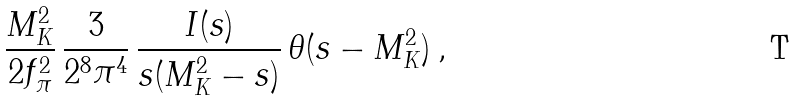Convert formula to latex. <formula><loc_0><loc_0><loc_500><loc_500>\frac { M _ { K } ^ { 2 } } { 2 f _ { \pi } ^ { 2 } } \, \frac { 3 } { 2 ^ { 8 } \pi ^ { 4 } } \, \frac { I ( s ) } { s ( M _ { K } ^ { 2 } - s ) } \, \theta ( s - M _ { K } ^ { 2 } ) \, ,</formula> 